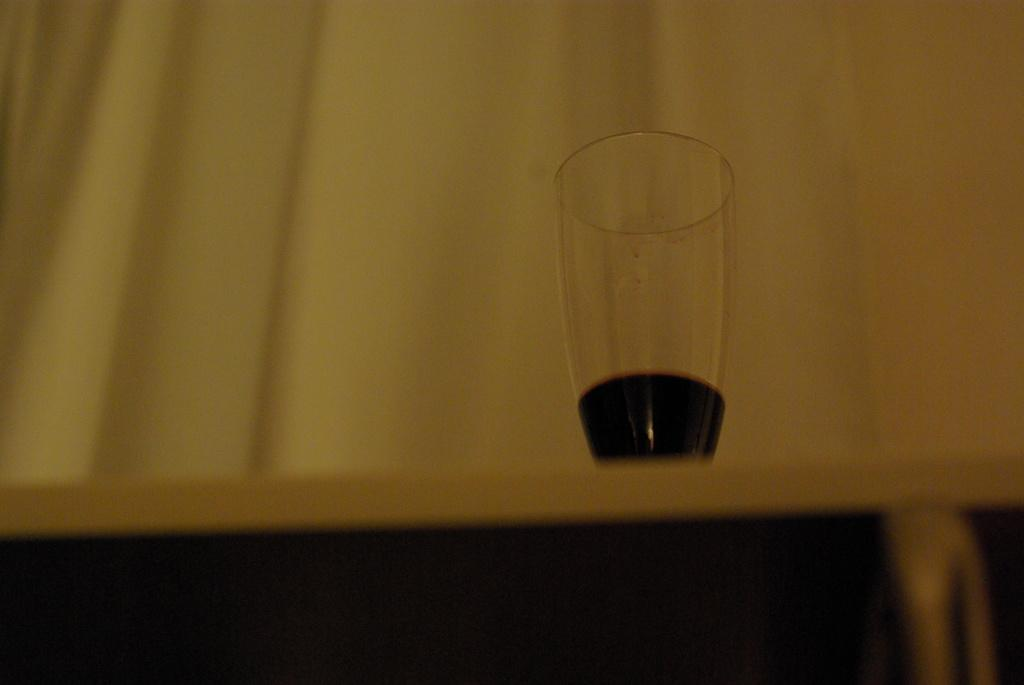What type of space is depicted in the image? There is a room in the image. What piece of furniture can be seen in the room? There is a table in the room. What is placed on the table? There is a wine glass on the table. What color is the curtain in the background? There is a yellow curtain in the background. How many pigs are visible in the image? There are no pigs present in the image. What type of work is being done in the office shown in the image? The image does not depict an office; it shows a room with a table and a wine glass. 